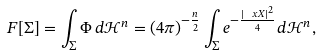<formula> <loc_0><loc_0><loc_500><loc_500>F [ \Sigma ] = \int _ { \Sigma } \Phi \, d \mathcal { H } ^ { n } = ( 4 \pi ) ^ { - \frac { n } { 2 } } \int _ { \Sigma } e ^ { - \frac { | \ x X | ^ { 2 } } { 4 } } d \mathcal { H } ^ { n } ,</formula> 